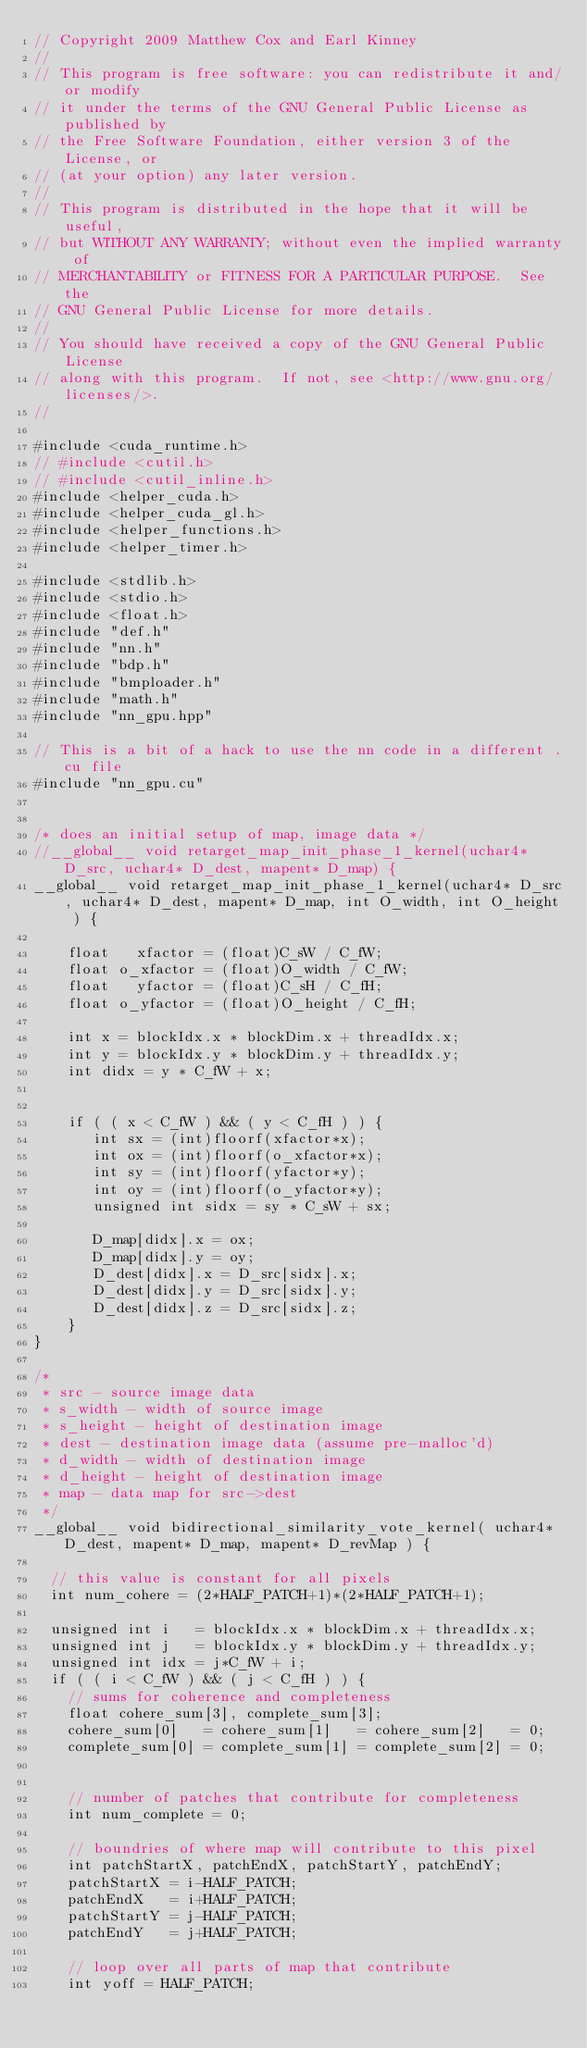<code> <loc_0><loc_0><loc_500><loc_500><_Cuda_>// Copyright 2009 Matthew Cox and Earl Kinney
//
// This program is free software: you can redistribute it and/or modify
// it under the terms of the GNU General Public License as published by
// the Free Software Foundation, either version 3 of the License, or
// (at your option) any later version.
//
// This program is distributed in the hope that it will be useful,
// but WITHOUT ANY WARRANTY; without even the implied warranty of
// MERCHANTABILITY or FITNESS FOR A PARTICULAR PURPOSE.  See the
// GNU General Public License for more details.
//
// You should have received a copy of the GNU General Public License
// along with this program.  If not, see <http://www.gnu.org/licenses/>.
//

#include <cuda_runtime.h>
// #include <cutil.h>
// #include <cutil_inline.h>
#include <helper_cuda.h>
#include <helper_cuda_gl.h>
#include <helper_functions.h>
#include <helper_timer.h>

#include <stdlib.h>
#include <stdio.h>
#include <float.h>
#include "def.h"
#include "nn.h"
#include "bdp.h"
#include "bmploader.h"
#include "math.h"
#include "nn_gpu.hpp"

// This is a bit of a hack to use the nn code in a different .cu file
#include "nn_gpu.cu"


/* does an initial setup of map, image data */
//__global__ void retarget_map_init_phase_1_kernel(uchar4* D_src, uchar4* D_dest, mapent* D_map) {
__global__ void retarget_map_init_phase_1_kernel(uchar4* D_src, uchar4* D_dest, mapent* D_map, int O_width, int O_height ) {

    float   xfactor = (float)C_sW / C_fW;
    float o_xfactor = (float)O_width / C_fW;
    float   yfactor = (float)C_sH / C_fH;
    float o_yfactor = (float)O_height / C_fH;

    int x = blockIdx.x * blockDim.x + threadIdx.x;
    int y = blockIdx.y * blockDim.y + threadIdx.y;
    int didx = y * C_fW + x;


    if ( ( x < C_fW ) && ( y < C_fH ) ) {
       int sx = (int)floorf(xfactor*x);
       int ox = (int)floorf(o_xfactor*x);
       int sy = (int)floorf(yfactor*y);
       int oy = (int)floorf(o_yfactor*y);
       unsigned int sidx = sy * C_sW + sx;
 
       D_map[didx].x = ox;
       D_map[didx].y = oy;
       D_dest[didx].x = D_src[sidx].x;
       D_dest[didx].y = D_src[sidx].y;
       D_dest[didx].z = D_src[sidx].z;
    }
}

/*
 * src - source image data
 * s_width - width of source image
 * s_height - height of destination image
 * dest - destination image data (assume pre-malloc'd)
 * d_width - width of destination image
 * d_height - height of destination image
 * map - data map for src->dest
 */
__global__ void bidirectional_similarity_vote_kernel( uchar4* D_dest, mapent* D_map, mapent* D_revMap ) {

  // this value is constant for all pixels
  int num_cohere = (2*HALF_PATCH+1)*(2*HALF_PATCH+1);

  unsigned int i   = blockIdx.x * blockDim.x + threadIdx.x;
  unsigned int j   = blockIdx.y * blockDim.y + threadIdx.y;
  unsigned int idx = j*C_fW + i;
  if ( ( i < C_fW ) && ( j < C_fH ) ) {
    // sums for coherence and completeness
    float cohere_sum[3], complete_sum[3];
    cohere_sum[0]   = cohere_sum[1]   = cohere_sum[2]   = 0;
    complete_sum[0] = complete_sum[1] = complete_sum[2] = 0;


    // number of patches that contribute for completeness
    int num_complete = 0;

    // boundries of where map will contribute to this pixel
    int patchStartX, patchEndX, patchStartY, patchEndY;
    patchStartX = i-HALF_PATCH;
    patchEndX   = i+HALF_PATCH;
    patchStartY = j-HALF_PATCH;
    patchEndY   = j+HALF_PATCH; 

    // loop over all parts of map that contribute
    int yoff = HALF_PATCH;</code> 